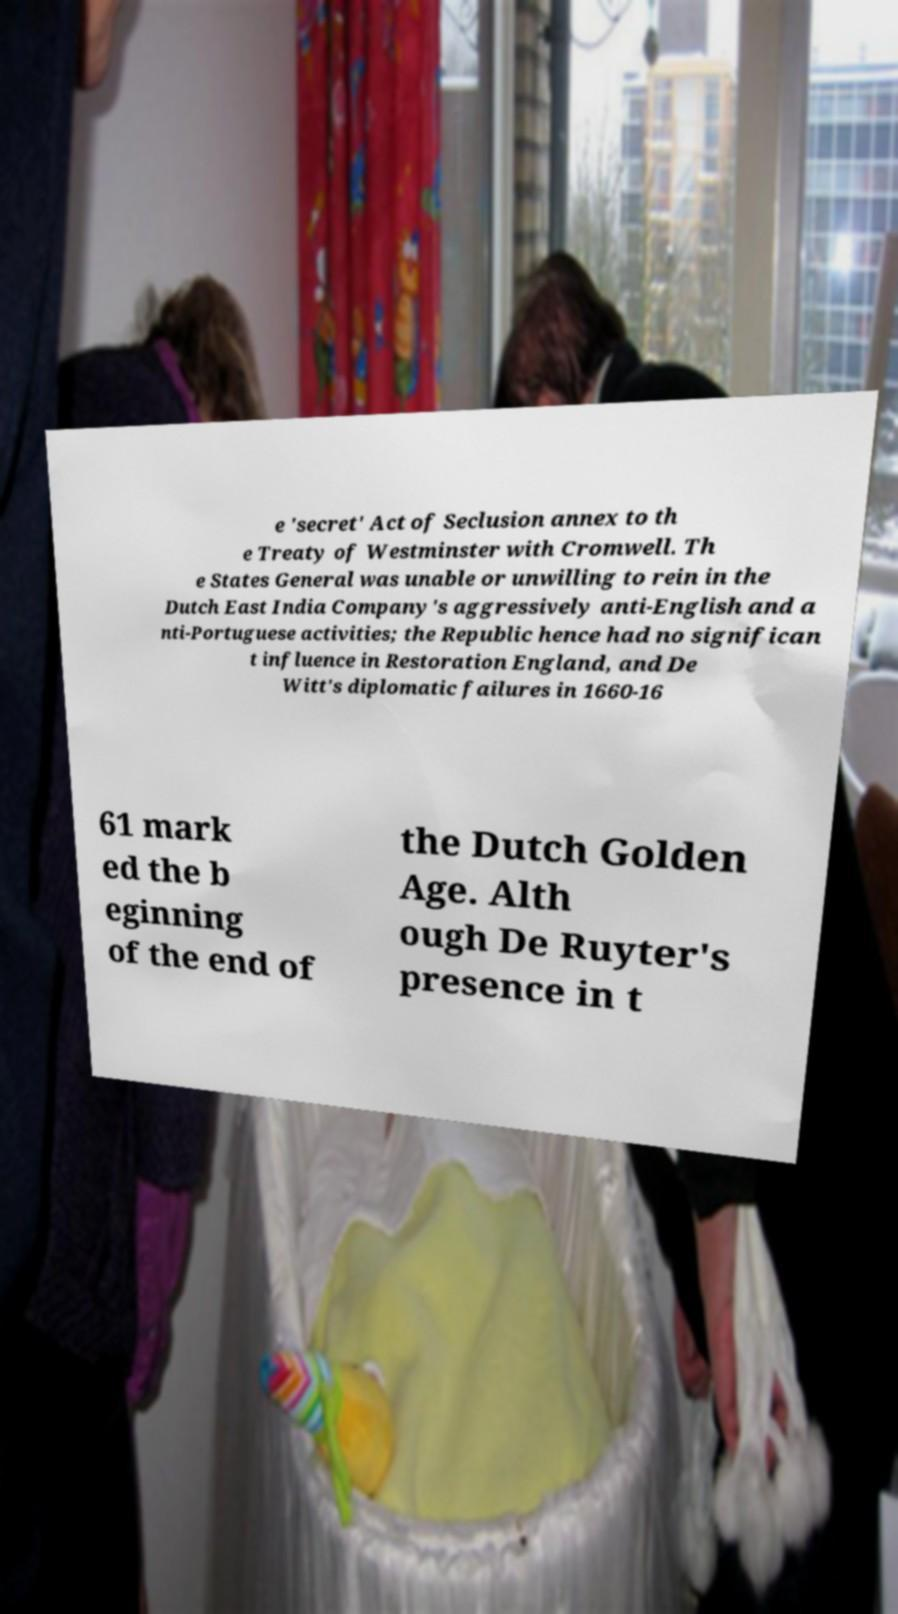Please read and relay the text visible in this image. What does it say? e 'secret' Act of Seclusion annex to th e Treaty of Westminster with Cromwell. Th e States General was unable or unwilling to rein in the Dutch East India Company's aggressively anti-English and a nti-Portuguese activities; the Republic hence had no significan t influence in Restoration England, and De Witt's diplomatic failures in 1660-16 61 mark ed the b eginning of the end of the Dutch Golden Age. Alth ough De Ruyter's presence in t 